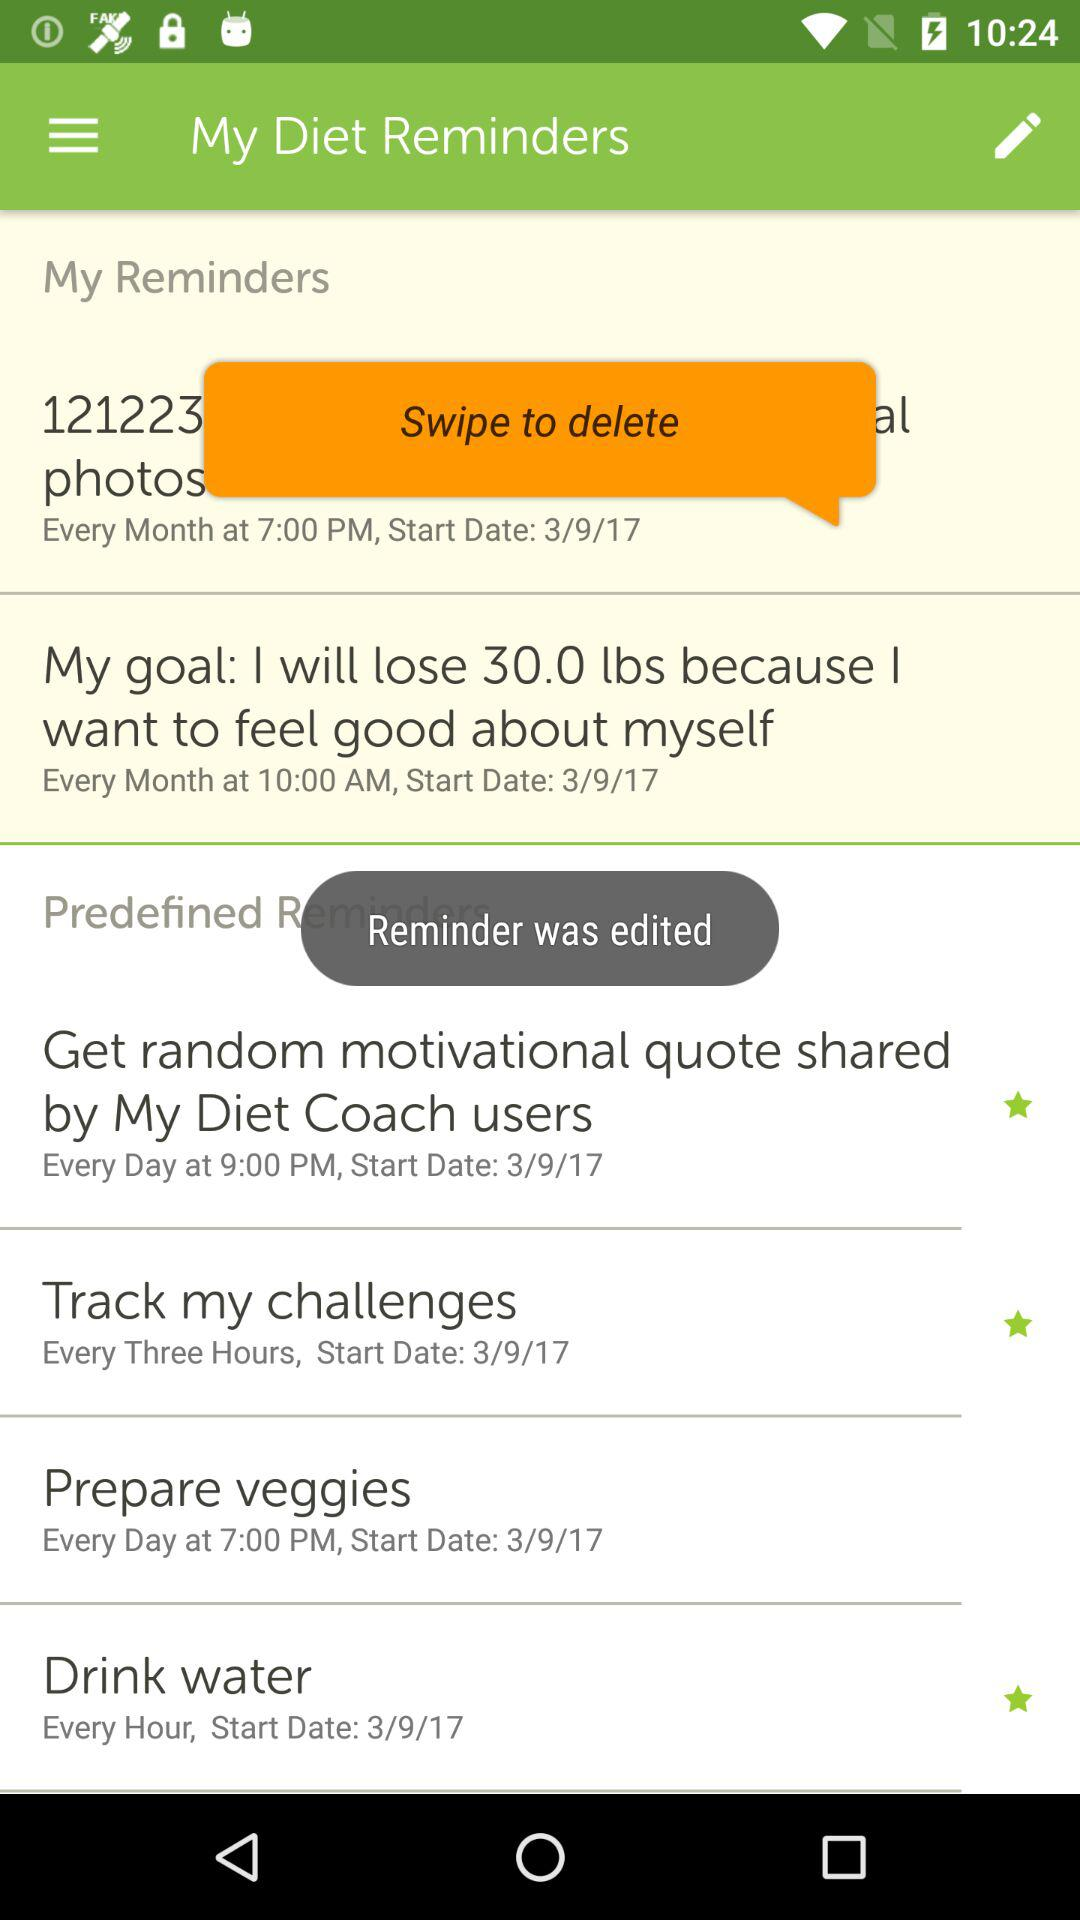What is the reminder set for every month at 10:00 AM? The reminder set for every month at 10:00 AM is "My goal: I will lose 30.0 lbs because I want to feel good about myself". 